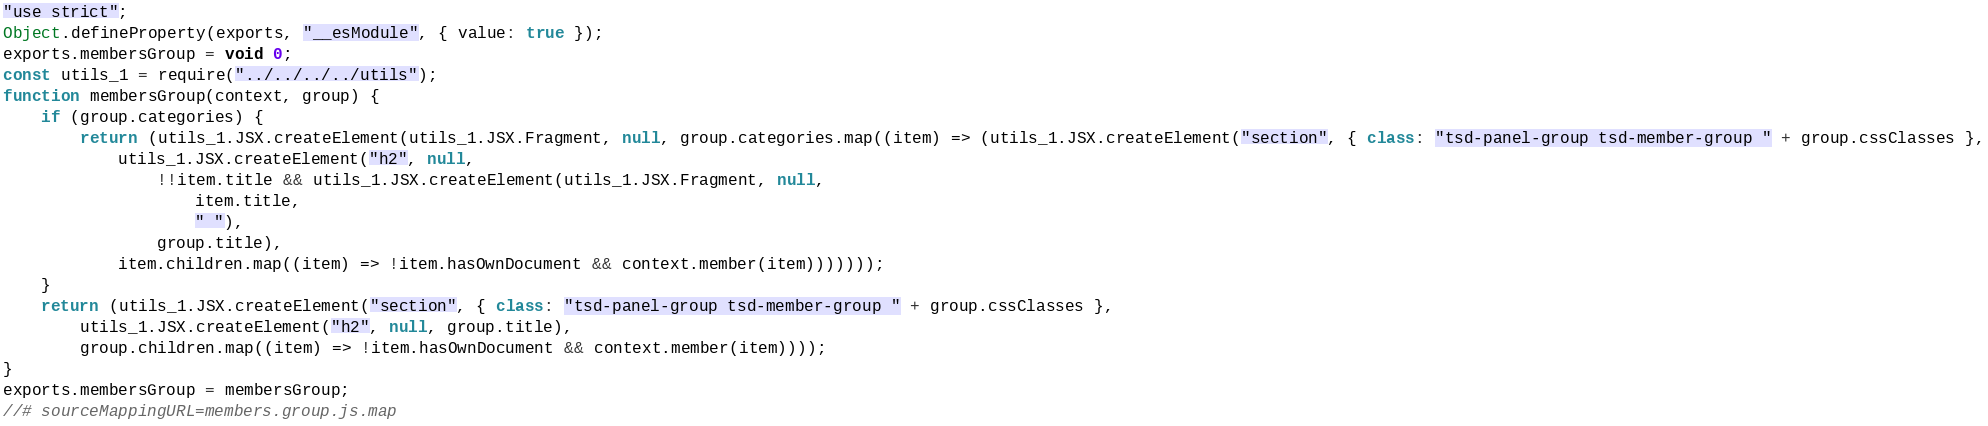<code> <loc_0><loc_0><loc_500><loc_500><_JavaScript_>"use strict";
Object.defineProperty(exports, "__esModule", { value: true });
exports.membersGroup = void 0;
const utils_1 = require("../../../../utils");
function membersGroup(context, group) {
    if (group.categories) {
        return (utils_1.JSX.createElement(utils_1.JSX.Fragment, null, group.categories.map((item) => (utils_1.JSX.createElement("section", { class: "tsd-panel-group tsd-member-group " + group.cssClasses },
            utils_1.JSX.createElement("h2", null,
                !!item.title && utils_1.JSX.createElement(utils_1.JSX.Fragment, null,
                    item.title,
                    " "),
                group.title),
            item.children.map((item) => !item.hasOwnDocument && context.member(item)))))));
    }
    return (utils_1.JSX.createElement("section", { class: "tsd-panel-group tsd-member-group " + group.cssClasses },
        utils_1.JSX.createElement("h2", null, group.title),
        group.children.map((item) => !item.hasOwnDocument && context.member(item))));
}
exports.membersGroup = membersGroup;
//# sourceMappingURL=members.group.js.map</code> 